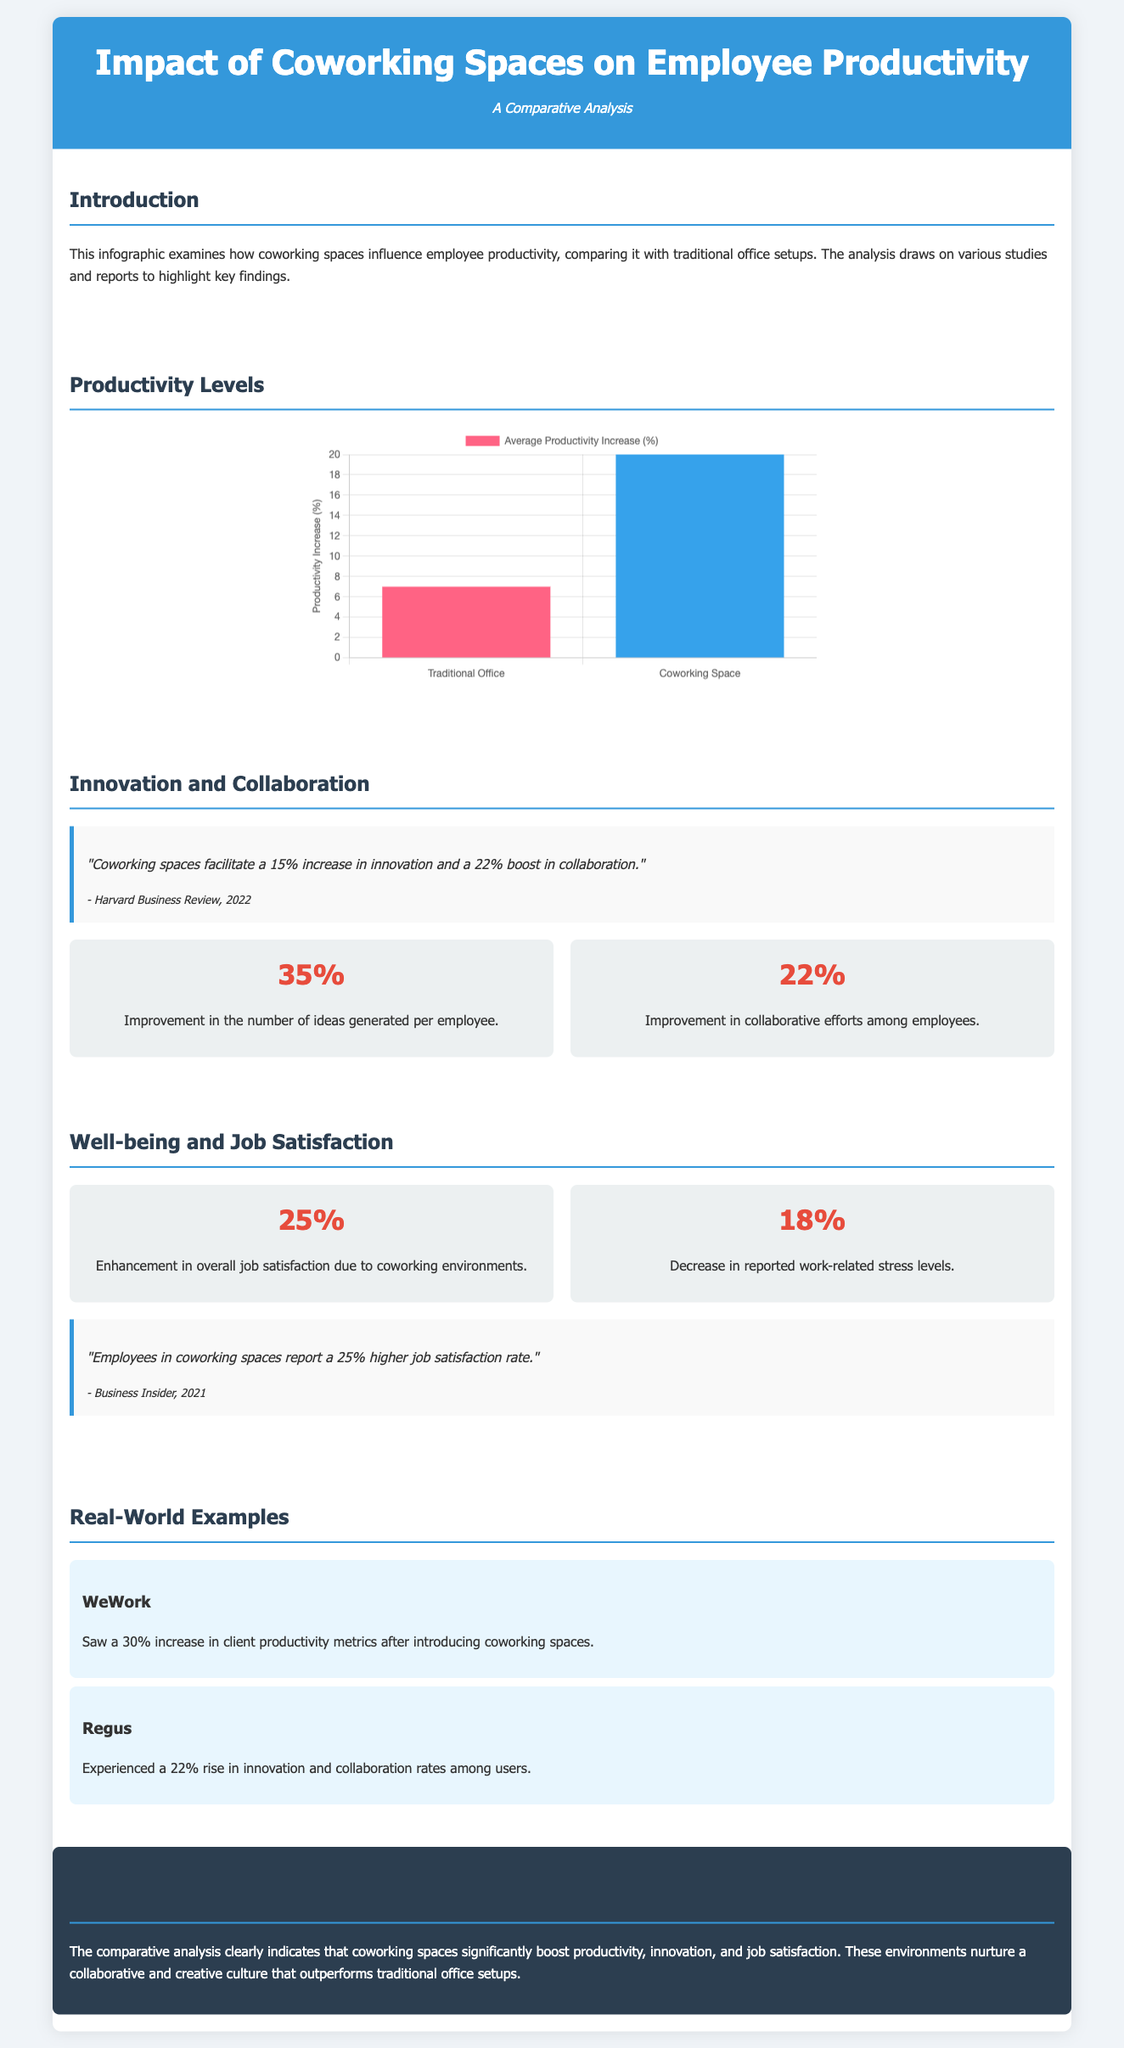What is the average productivity increase in traditional offices? The document states that the average productivity increase in traditional offices is 7%.
Answer: 7% What is the reported percentage increase in ideas generated per employee in coworking spaces? The infographic mentions a 35% improvement in the number of ideas generated per employee in coworking spaces.
Answer: 35% What publication reported a 25% higher job satisfaction rate in coworking spaces? Business Insider reported this statistic about job satisfaction rates in coworking spaces.
Answer: Business Insider What is the percentage of decrease in reported work-related stress levels? The document indicates an 18% decrease in reported work-related stress levels.
Answer: 18% How much did WeWork clients' productivity metrics increase? The document states that WeWork saw a 30% increase in client productivity metrics.
Answer: 30% What is the title of the infographic? The title of the infographic is "Impact of Coworking Spaces on Employee Productivity".
Answer: Impact of Coworking Spaces on Employee Productivity What is the percentage boost in collaboration reported by Harvard Business Review? The document states there is a 22% boost in collaboration reported by Harvard Business Review.
Answer: 22% What type of document is this? This is a statistical infographic.
Answer: Statistical infographic 